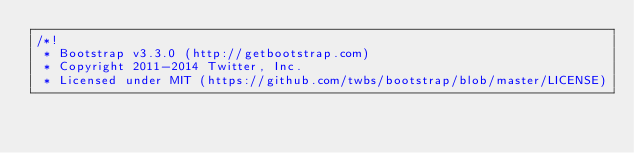Convert code to text. <code><loc_0><loc_0><loc_500><loc_500><_CSS_>/*!
 * Bootstrap v3.3.0 (http://getbootstrap.com)
 * Copyright 2011-2014 Twitter, Inc.
 * Licensed under MIT (https://github.com/twbs/bootstrap/blob/master/LICENSE)</code> 